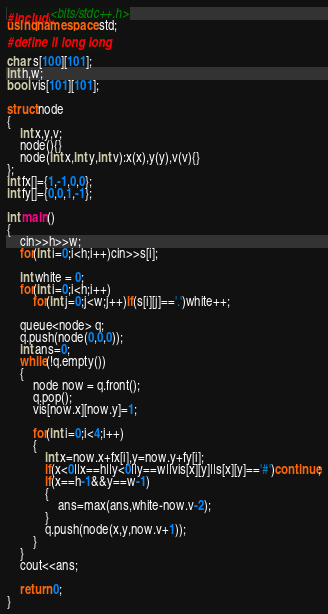Convert code to text. <code><loc_0><loc_0><loc_500><loc_500><_C++_>#include<bits/stdc++.h>
using namespace std;
#define ll long long

char s[100][101];
int h,w;
bool vis[101][101];

struct node
{
    int x,y,v;
    node(){}
    node(int x,int y,int v):x(x),y(y),v(v){}
};
int fx[]={1,-1,0,0};
int fy[]={0,0,1,-1};

int main()
{
    cin>>h>>w;
    for(int i=0;i<h;i++)cin>>s[i];

    int white = 0;
    for(int i=0;i<h;i++)
        for(int j=0;j<w;j++)if(s[i][j]=='.')white++;

    queue<node> q;
    q.push(node(0,0,0));
    int ans=0;
    while(!q.empty())
    {
        node now = q.front();
        q.pop();
        vis[now.x][now.y]=1;

        for(int i=0;i<4;i++)
        {
            int x=now.x+fx[i],y=now.y+fy[i];
            if(x<0||x==h||y<0||y==w||vis[x][y]||s[x][y]=='#')continue;
            if(x==h-1&&y==w-1)
            {
                ans=max(ans,white-now.v-2);
            }
            q.push(node(x,y,now.v+1));
        }
    }
    cout<<ans;

    return 0;
}
</code> 